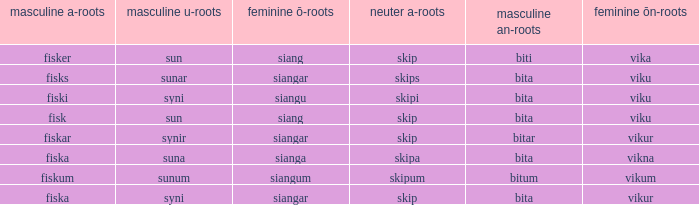What is the masculine u form for the old Swedish word with a neuter a form of skipum? Sunum. Could you parse the entire table? {'header': ['masculine a-roots', 'masculine u-roots', 'feminine ō-roots', 'neuter a-roots', 'masculine an-roots', 'feminine ōn-roots'], 'rows': [['fisker', 'sun', 'siang', 'skip', 'biti', 'vika'], ['fisks', 'sunar', 'siangar', 'skips', 'bita', 'viku'], ['fiski', 'syni', 'siangu', 'skipi', 'bita', 'viku'], ['fisk', 'sun', 'siang', 'skip', 'bita', 'viku'], ['fiskar', 'synir', 'siangar', 'skip', 'bitar', 'vikur'], ['fiska', 'suna', 'sianga', 'skipa', 'bita', 'vikna'], ['fiskum', 'sunum', 'siangum', 'skipum', 'bitum', 'vikum'], ['fiska', 'syni', 'siangar', 'skip', 'bita', 'vikur']]} 